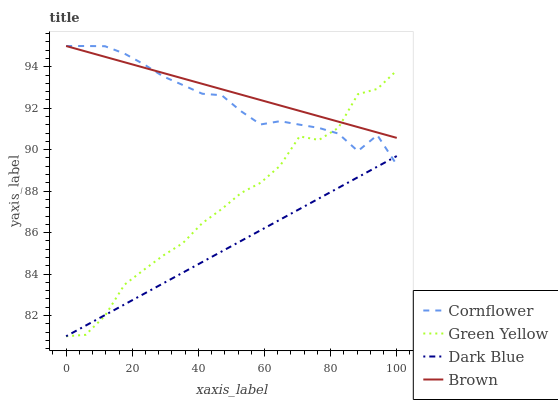Does Dark Blue have the minimum area under the curve?
Answer yes or no. Yes. Does Brown have the maximum area under the curve?
Answer yes or no. Yes. Does Green Yellow have the minimum area under the curve?
Answer yes or no. No. Does Green Yellow have the maximum area under the curve?
Answer yes or no. No. Is Brown the smoothest?
Answer yes or no. Yes. Is Green Yellow the roughest?
Answer yes or no. Yes. Is Green Yellow the smoothest?
Answer yes or no. No. Is Brown the roughest?
Answer yes or no. No. Does Green Yellow have the lowest value?
Answer yes or no. Yes. Does Brown have the lowest value?
Answer yes or no. No. Does Brown have the highest value?
Answer yes or no. Yes. Does Green Yellow have the highest value?
Answer yes or no. No. Is Dark Blue less than Brown?
Answer yes or no. Yes. Is Brown greater than Dark Blue?
Answer yes or no. Yes. Does Cornflower intersect Dark Blue?
Answer yes or no. Yes. Is Cornflower less than Dark Blue?
Answer yes or no. No. Is Cornflower greater than Dark Blue?
Answer yes or no. No. Does Dark Blue intersect Brown?
Answer yes or no. No. 